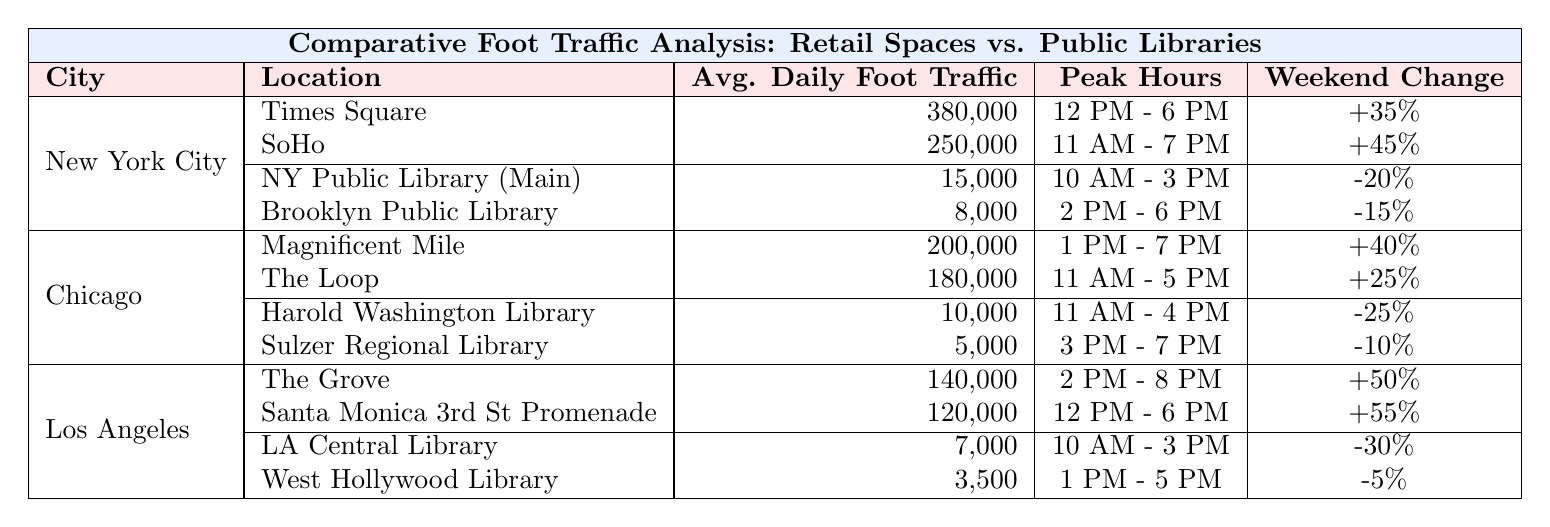What is the average daily foot traffic at Times Square? According to the table, the average daily foot traffic at Times Square is listed as 380,000.
Answer: 380,000 Which public library in New York City has the higher average daily foot traffic? The New York Public Library (Main Branch) has 15,000 daily foot traffic, which is higher than Brooklyn Public Library's 8,000.
Answer: New York Public Library (Main Branch) What is the weekend increase percentage for retail spaces in Chicago? The retail spaces in Chicago have a weekend increase of 40% for Magnificent Mile and 25% for The Loop, which indicates a mix of increases from both locations.
Answer: 40% (Magnificent Mile) How many retail locations in Los Angeles have an average daily foot traffic over 100,000? Two retail locations in Los Angeles exceed 100,000 in average daily foot traffic: The Grove at 140,000 and Santa Monica Third Street Promenade at 120,000.
Answer: 2 What is the total average daily foot traffic for all public libraries in New York City? The average daily foot traffic at both libraries is 15,000 + 8,000 = 23,000.
Answer: 23,000 Do any retail spaces have a weekend increase over 50% in Los Angeles? Yes, both The Grove and Santa Monica Third Street Promenade have weekend increases of 50% and 55%, respectively, which is above 50%.
Answer: Yes Calculate the percentage difference in average daily foot traffic between the busiest retail space in NYC and the busiest public library. The difference is 380,000 (Times Square) - 15,000 (NY Public Library) = 365,000, and the percentage is (365,000/15,000)*100 = 2,433.33%.
Answer: 2433.33% Which city has the highest peak hours for retail spaces between 12 PM to 6 PM? New York City has the retail locations (Times Square and SoHo) peaking between 12 PM to 6 PM, while other cities peak outside of this timeframe.
Answer: New York City Which library in Los Angeles has the lowest average daily foot traffic? The West Hollywood Library has the lowest average daily foot traffic at 3,500.
Answer: West Hollywood Library How do the weekend changes compare between retail spaces in Chicago and public libraries in the same city? Retail spaces in Chicago show a weekend increase of 40% and 25%, while public libraries show a decrease of 25% and 10%. Retail spaces are experiencing increases, while libraries are experiencing decreases.
Answer: Retail spaces increase; libraries decrease 